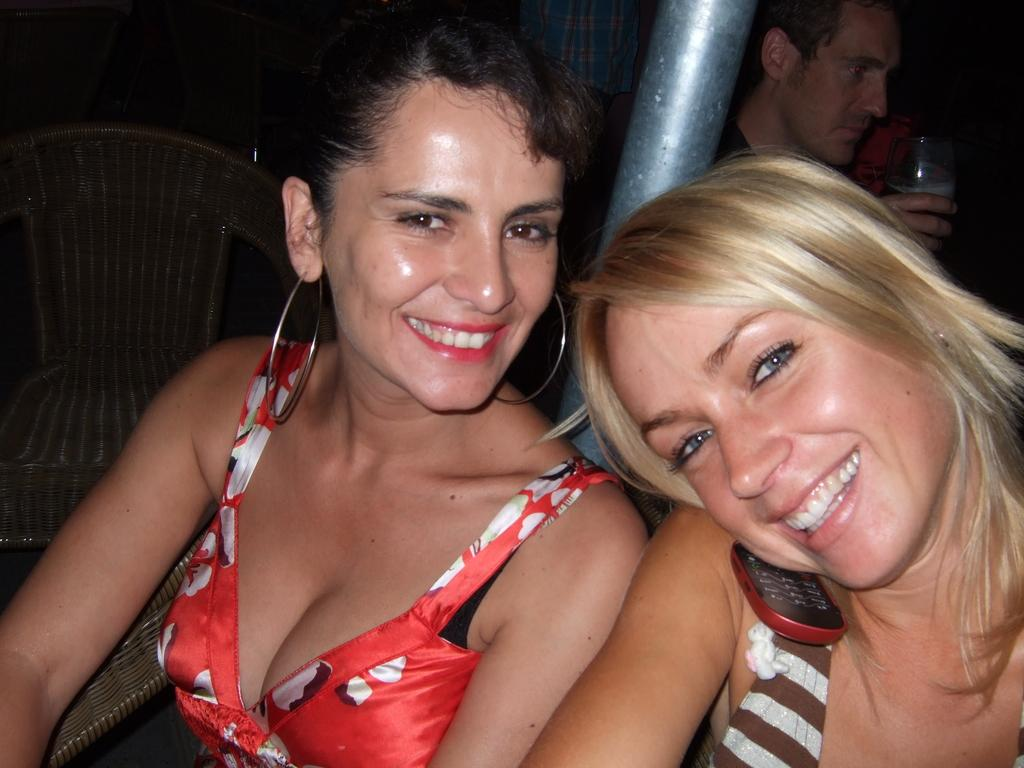How many people are in the center of the image? There are two girls in the center of the image. What is located behind the girls? There is a pole behind the girls. Can you describe the background area of the image? In the background area of the image, there is a boy and a chair. What type of bells can be heard ringing in the image? There are no bells present in the image, and therefore no sound can be heard. 